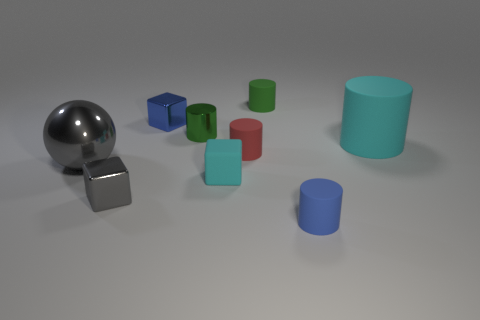Subtract all blue cylinders. How many cylinders are left? 4 Subtract all brown cylinders. Subtract all brown spheres. How many cylinders are left? 5 Add 1 cyan metal blocks. How many objects exist? 10 Subtract all cylinders. How many objects are left? 4 Add 9 blue cylinders. How many blue cylinders exist? 10 Subtract 0 brown cylinders. How many objects are left? 9 Subtract all gray balls. Subtract all tiny red things. How many objects are left? 7 Add 7 large objects. How many large objects are left? 9 